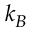Convert formula to latex. <formula><loc_0><loc_0><loc_500><loc_500>k _ { B }</formula> 